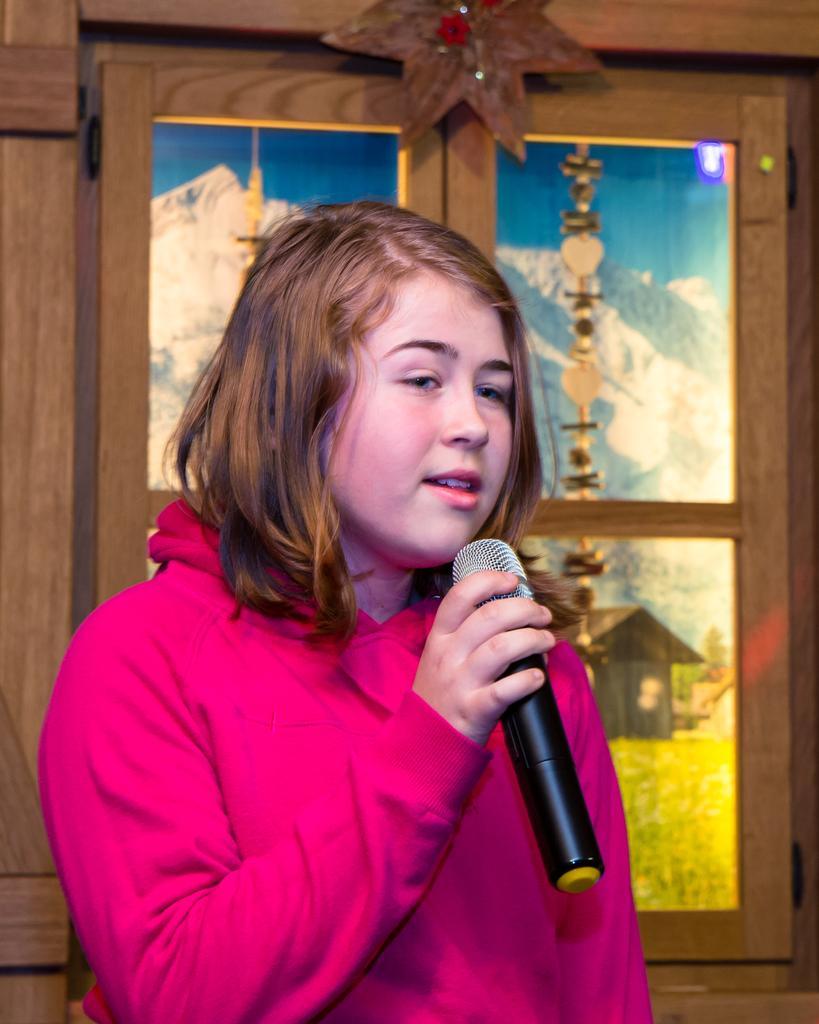Could you give a brief overview of what you see in this image? In this image, there is a person wearing clothes and holding a mic with her hand. There is a window behind this person. 